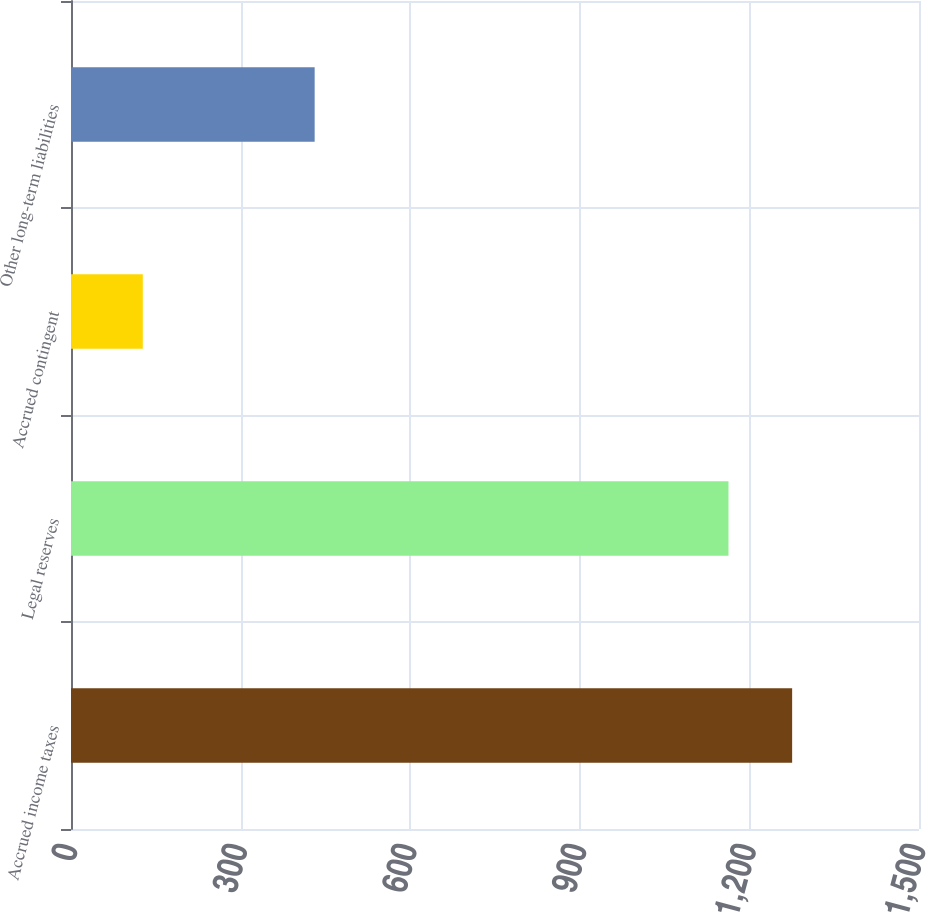Convert chart. <chart><loc_0><loc_0><loc_500><loc_500><bar_chart><fcel>Accrued income taxes<fcel>Legal reserves<fcel>Accrued contingent<fcel>Other long-term liabilities<nl><fcel>1275.6<fcel>1163<fcel>127<fcel>431<nl></chart> 